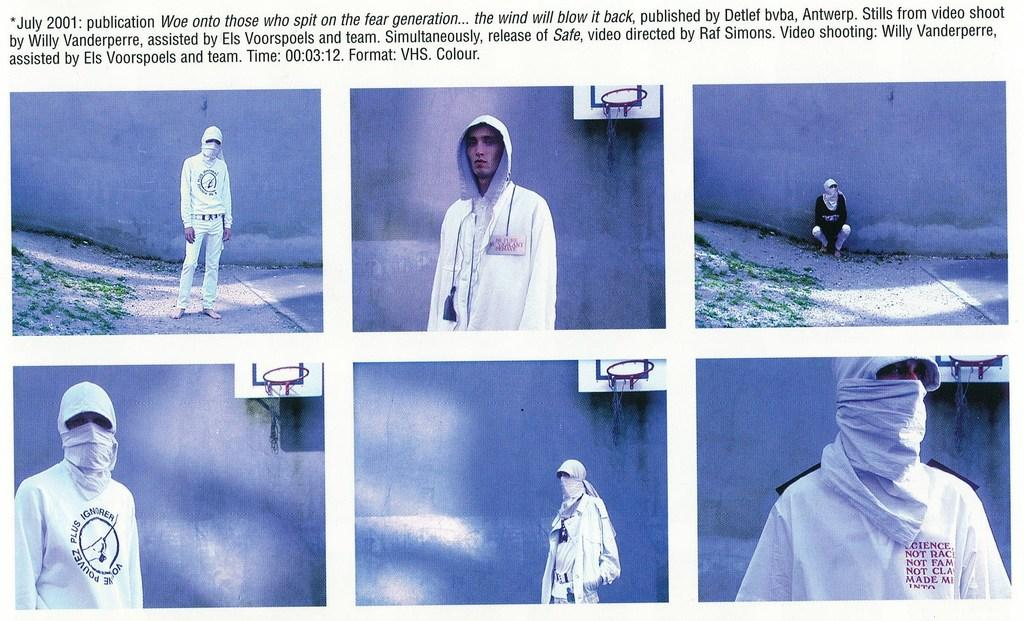What type of artwork is the image? The image is a collage. Who or what is depicted in the image? There is a man shown from different angles in the image. What sports equipment is visible in the image? There is a basketball hoop in the image. What can be seen in the background of the image? There is a wall in the background of the image. What additional elements are present in the image? There are words and numbers present in the image. What type of kite is the man flying in the image? There is no kite present in the image; it features a man and a basketball hoop. What kind of meat is the man holding in the image? There is no meat present in the image; it only shows a man and a basketball hoop. 